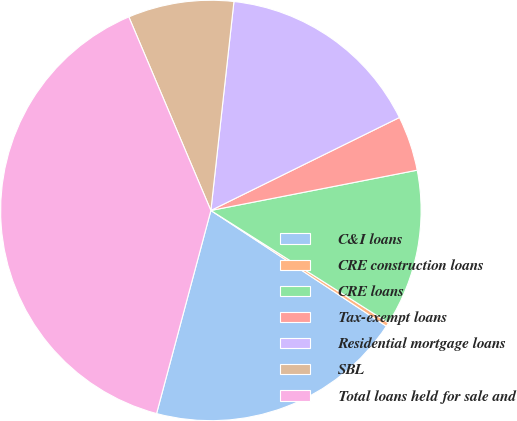Convert chart. <chart><loc_0><loc_0><loc_500><loc_500><pie_chart><fcel>C&I loans<fcel>CRE construction loans<fcel>CRE loans<fcel>Tax-exempt loans<fcel>Residential mortgage loans<fcel>SBL<fcel>Total loans held for sale and<nl><fcel>19.88%<fcel>0.3%<fcel>12.05%<fcel>4.22%<fcel>15.96%<fcel>8.13%<fcel>39.46%<nl></chart> 